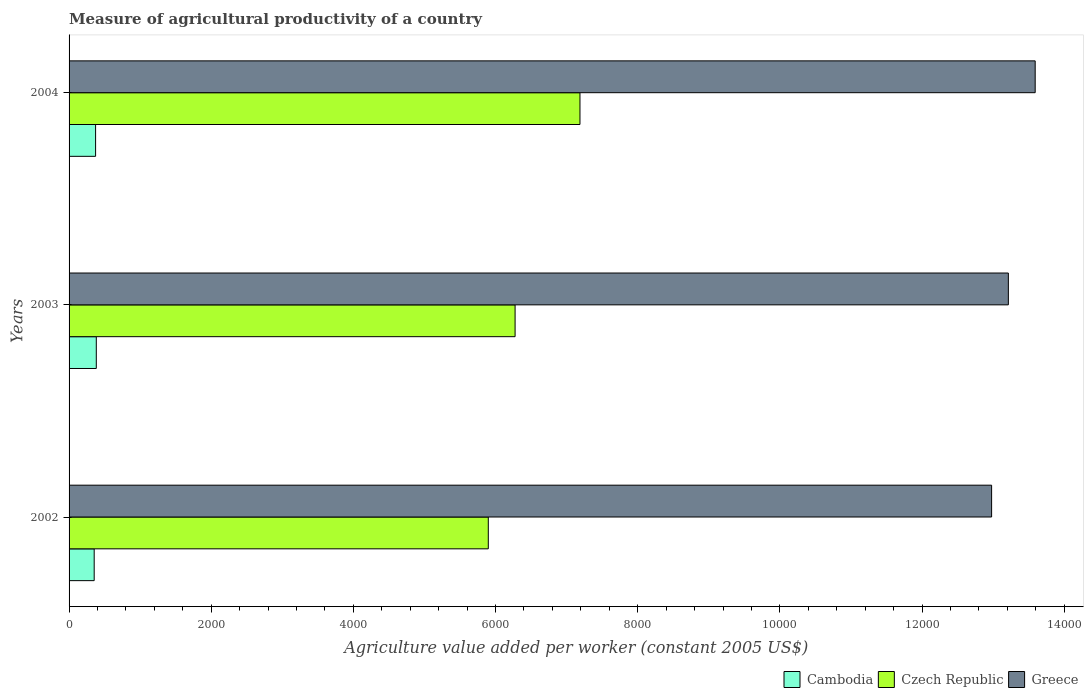How many different coloured bars are there?
Provide a succinct answer. 3. How many groups of bars are there?
Give a very brief answer. 3. In how many cases, is the number of bars for a given year not equal to the number of legend labels?
Keep it short and to the point. 0. What is the measure of agricultural productivity in Cambodia in 2004?
Ensure brevity in your answer.  373.2. Across all years, what is the maximum measure of agricultural productivity in Greece?
Ensure brevity in your answer.  1.36e+04. Across all years, what is the minimum measure of agricultural productivity in Cambodia?
Give a very brief answer. 353.29. What is the total measure of agricultural productivity in Cambodia in the graph?
Keep it short and to the point. 1109.63. What is the difference between the measure of agricultural productivity in Cambodia in 2002 and that in 2004?
Provide a succinct answer. -19.91. What is the difference between the measure of agricultural productivity in Greece in 2004 and the measure of agricultural productivity in Cambodia in 2003?
Your response must be concise. 1.32e+04. What is the average measure of agricultural productivity in Czech Republic per year?
Make the answer very short. 6453.63. In the year 2002, what is the difference between the measure of agricultural productivity in Greece and measure of agricultural productivity in Cambodia?
Your answer should be compact. 1.26e+04. What is the ratio of the measure of agricultural productivity in Czech Republic in 2002 to that in 2004?
Make the answer very short. 0.82. What is the difference between the highest and the second highest measure of agricultural productivity in Czech Republic?
Make the answer very short. 912.7. What is the difference between the highest and the lowest measure of agricultural productivity in Cambodia?
Provide a succinct answer. 29.85. In how many years, is the measure of agricultural productivity in Greece greater than the average measure of agricultural productivity in Greece taken over all years?
Give a very brief answer. 1. Is the sum of the measure of agricultural productivity in Greece in 2002 and 2004 greater than the maximum measure of agricultural productivity in Cambodia across all years?
Offer a terse response. Yes. What does the 2nd bar from the top in 2002 represents?
Your answer should be compact. Czech Republic. What does the 3rd bar from the bottom in 2003 represents?
Provide a succinct answer. Greece. Is it the case that in every year, the sum of the measure of agricultural productivity in Greece and measure of agricultural productivity in Cambodia is greater than the measure of agricultural productivity in Czech Republic?
Your answer should be very brief. Yes. How many bars are there?
Provide a short and direct response. 9. Are all the bars in the graph horizontal?
Provide a succinct answer. Yes. Does the graph contain grids?
Keep it short and to the point. No. Where does the legend appear in the graph?
Keep it short and to the point. Bottom right. How many legend labels are there?
Provide a short and direct response. 3. How are the legend labels stacked?
Provide a short and direct response. Horizontal. What is the title of the graph?
Provide a short and direct response. Measure of agricultural productivity of a country. Does "Small states" appear as one of the legend labels in the graph?
Ensure brevity in your answer.  No. What is the label or title of the X-axis?
Make the answer very short. Agriculture value added per worker (constant 2005 US$). What is the label or title of the Y-axis?
Your response must be concise. Years. What is the Agriculture value added per worker (constant 2005 US$) of Cambodia in 2002?
Provide a succinct answer. 353.29. What is the Agriculture value added per worker (constant 2005 US$) of Czech Republic in 2002?
Provide a short and direct response. 5898.01. What is the Agriculture value added per worker (constant 2005 US$) in Greece in 2002?
Your response must be concise. 1.30e+04. What is the Agriculture value added per worker (constant 2005 US$) in Cambodia in 2003?
Your response must be concise. 383.14. What is the Agriculture value added per worker (constant 2005 US$) of Czech Republic in 2003?
Your answer should be very brief. 6275.09. What is the Agriculture value added per worker (constant 2005 US$) in Greece in 2003?
Your answer should be very brief. 1.32e+04. What is the Agriculture value added per worker (constant 2005 US$) in Cambodia in 2004?
Ensure brevity in your answer.  373.2. What is the Agriculture value added per worker (constant 2005 US$) of Czech Republic in 2004?
Offer a terse response. 7187.79. What is the Agriculture value added per worker (constant 2005 US$) of Greece in 2004?
Give a very brief answer. 1.36e+04. Across all years, what is the maximum Agriculture value added per worker (constant 2005 US$) in Cambodia?
Your answer should be very brief. 383.14. Across all years, what is the maximum Agriculture value added per worker (constant 2005 US$) of Czech Republic?
Give a very brief answer. 7187.79. Across all years, what is the maximum Agriculture value added per worker (constant 2005 US$) in Greece?
Offer a very short reply. 1.36e+04. Across all years, what is the minimum Agriculture value added per worker (constant 2005 US$) of Cambodia?
Give a very brief answer. 353.29. Across all years, what is the minimum Agriculture value added per worker (constant 2005 US$) of Czech Republic?
Offer a very short reply. 5898.01. Across all years, what is the minimum Agriculture value added per worker (constant 2005 US$) in Greece?
Ensure brevity in your answer.  1.30e+04. What is the total Agriculture value added per worker (constant 2005 US$) of Cambodia in the graph?
Ensure brevity in your answer.  1109.63. What is the total Agriculture value added per worker (constant 2005 US$) of Czech Republic in the graph?
Offer a very short reply. 1.94e+04. What is the total Agriculture value added per worker (constant 2005 US$) in Greece in the graph?
Give a very brief answer. 3.98e+04. What is the difference between the Agriculture value added per worker (constant 2005 US$) in Cambodia in 2002 and that in 2003?
Give a very brief answer. -29.85. What is the difference between the Agriculture value added per worker (constant 2005 US$) of Czech Republic in 2002 and that in 2003?
Ensure brevity in your answer.  -377.08. What is the difference between the Agriculture value added per worker (constant 2005 US$) in Greece in 2002 and that in 2003?
Give a very brief answer. -235.66. What is the difference between the Agriculture value added per worker (constant 2005 US$) of Cambodia in 2002 and that in 2004?
Make the answer very short. -19.91. What is the difference between the Agriculture value added per worker (constant 2005 US$) in Czech Republic in 2002 and that in 2004?
Provide a short and direct response. -1289.78. What is the difference between the Agriculture value added per worker (constant 2005 US$) in Greece in 2002 and that in 2004?
Offer a very short reply. -613.14. What is the difference between the Agriculture value added per worker (constant 2005 US$) in Cambodia in 2003 and that in 2004?
Make the answer very short. 9.94. What is the difference between the Agriculture value added per worker (constant 2005 US$) in Czech Republic in 2003 and that in 2004?
Give a very brief answer. -912.7. What is the difference between the Agriculture value added per worker (constant 2005 US$) of Greece in 2003 and that in 2004?
Your response must be concise. -377.48. What is the difference between the Agriculture value added per worker (constant 2005 US$) in Cambodia in 2002 and the Agriculture value added per worker (constant 2005 US$) in Czech Republic in 2003?
Keep it short and to the point. -5921.8. What is the difference between the Agriculture value added per worker (constant 2005 US$) of Cambodia in 2002 and the Agriculture value added per worker (constant 2005 US$) of Greece in 2003?
Provide a short and direct response. -1.29e+04. What is the difference between the Agriculture value added per worker (constant 2005 US$) in Czech Republic in 2002 and the Agriculture value added per worker (constant 2005 US$) in Greece in 2003?
Your response must be concise. -7316.71. What is the difference between the Agriculture value added per worker (constant 2005 US$) in Cambodia in 2002 and the Agriculture value added per worker (constant 2005 US$) in Czech Republic in 2004?
Ensure brevity in your answer.  -6834.49. What is the difference between the Agriculture value added per worker (constant 2005 US$) in Cambodia in 2002 and the Agriculture value added per worker (constant 2005 US$) in Greece in 2004?
Your answer should be very brief. -1.32e+04. What is the difference between the Agriculture value added per worker (constant 2005 US$) in Czech Republic in 2002 and the Agriculture value added per worker (constant 2005 US$) in Greece in 2004?
Provide a short and direct response. -7694.2. What is the difference between the Agriculture value added per worker (constant 2005 US$) of Cambodia in 2003 and the Agriculture value added per worker (constant 2005 US$) of Czech Republic in 2004?
Your response must be concise. -6804.65. What is the difference between the Agriculture value added per worker (constant 2005 US$) in Cambodia in 2003 and the Agriculture value added per worker (constant 2005 US$) in Greece in 2004?
Give a very brief answer. -1.32e+04. What is the difference between the Agriculture value added per worker (constant 2005 US$) of Czech Republic in 2003 and the Agriculture value added per worker (constant 2005 US$) of Greece in 2004?
Provide a succinct answer. -7317.12. What is the average Agriculture value added per worker (constant 2005 US$) of Cambodia per year?
Keep it short and to the point. 369.88. What is the average Agriculture value added per worker (constant 2005 US$) of Czech Republic per year?
Offer a very short reply. 6453.63. What is the average Agriculture value added per worker (constant 2005 US$) of Greece per year?
Offer a very short reply. 1.33e+04. In the year 2002, what is the difference between the Agriculture value added per worker (constant 2005 US$) of Cambodia and Agriculture value added per worker (constant 2005 US$) of Czech Republic?
Your answer should be compact. -5544.71. In the year 2002, what is the difference between the Agriculture value added per worker (constant 2005 US$) in Cambodia and Agriculture value added per worker (constant 2005 US$) in Greece?
Provide a short and direct response. -1.26e+04. In the year 2002, what is the difference between the Agriculture value added per worker (constant 2005 US$) of Czech Republic and Agriculture value added per worker (constant 2005 US$) of Greece?
Make the answer very short. -7081.06. In the year 2003, what is the difference between the Agriculture value added per worker (constant 2005 US$) in Cambodia and Agriculture value added per worker (constant 2005 US$) in Czech Republic?
Provide a succinct answer. -5891.95. In the year 2003, what is the difference between the Agriculture value added per worker (constant 2005 US$) of Cambodia and Agriculture value added per worker (constant 2005 US$) of Greece?
Offer a very short reply. -1.28e+04. In the year 2003, what is the difference between the Agriculture value added per worker (constant 2005 US$) in Czech Republic and Agriculture value added per worker (constant 2005 US$) in Greece?
Provide a short and direct response. -6939.63. In the year 2004, what is the difference between the Agriculture value added per worker (constant 2005 US$) of Cambodia and Agriculture value added per worker (constant 2005 US$) of Czech Republic?
Your answer should be very brief. -6814.59. In the year 2004, what is the difference between the Agriculture value added per worker (constant 2005 US$) of Cambodia and Agriculture value added per worker (constant 2005 US$) of Greece?
Your answer should be compact. -1.32e+04. In the year 2004, what is the difference between the Agriculture value added per worker (constant 2005 US$) in Czech Republic and Agriculture value added per worker (constant 2005 US$) in Greece?
Your answer should be very brief. -6404.42. What is the ratio of the Agriculture value added per worker (constant 2005 US$) of Cambodia in 2002 to that in 2003?
Provide a succinct answer. 0.92. What is the ratio of the Agriculture value added per worker (constant 2005 US$) of Czech Republic in 2002 to that in 2003?
Offer a terse response. 0.94. What is the ratio of the Agriculture value added per worker (constant 2005 US$) in Greece in 2002 to that in 2003?
Give a very brief answer. 0.98. What is the ratio of the Agriculture value added per worker (constant 2005 US$) of Cambodia in 2002 to that in 2004?
Your answer should be very brief. 0.95. What is the ratio of the Agriculture value added per worker (constant 2005 US$) of Czech Republic in 2002 to that in 2004?
Provide a short and direct response. 0.82. What is the ratio of the Agriculture value added per worker (constant 2005 US$) of Greece in 2002 to that in 2004?
Offer a very short reply. 0.95. What is the ratio of the Agriculture value added per worker (constant 2005 US$) of Cambodia in 2003 to that in 2004?
Your answer should be compact. 1.03. What is the ratio of the Agriculture value added per worker (constant 2005 US$) of Czech Republic in 2003 to that in 2004?
Your response must be concise. 0.87. What is the ratio of the Agriculture value added per worker (constant 2005 US$) of Greece in 2003 to that in 2004?
Your response must be concise. 0.97. What is the difference between the highest and the second highest Agriculture value added per worker (constant 2005 US$) of Cambodia?
Provide a succinct answer. 9.94. What is the difference between the highest and the second highest Agriculture value added per worker (constant 2005 US$) in Czech Republic?
Make the answer very short. 912.7. What is the difference between the highest and the second highest Agriculture value added per worker (constant 2005 US$) in Greece?
Offer a very short reply. 377.48. What is the difference between the highest and the lowest Agriculture value added per worker (constant 2005 US$) of Cambodia?
Keep it short and to the point. 29.85. What is the difference between the highest and the lowest Agriculture value added per worker (constant 2005 US$) of Czech Republic?
Provide a short and direct response. 1289.78. What is the difference between the highest and the lowest Agriculture value added per worker (constant 2005 US$) of Greece?
Make the answer very short. 613.14. 